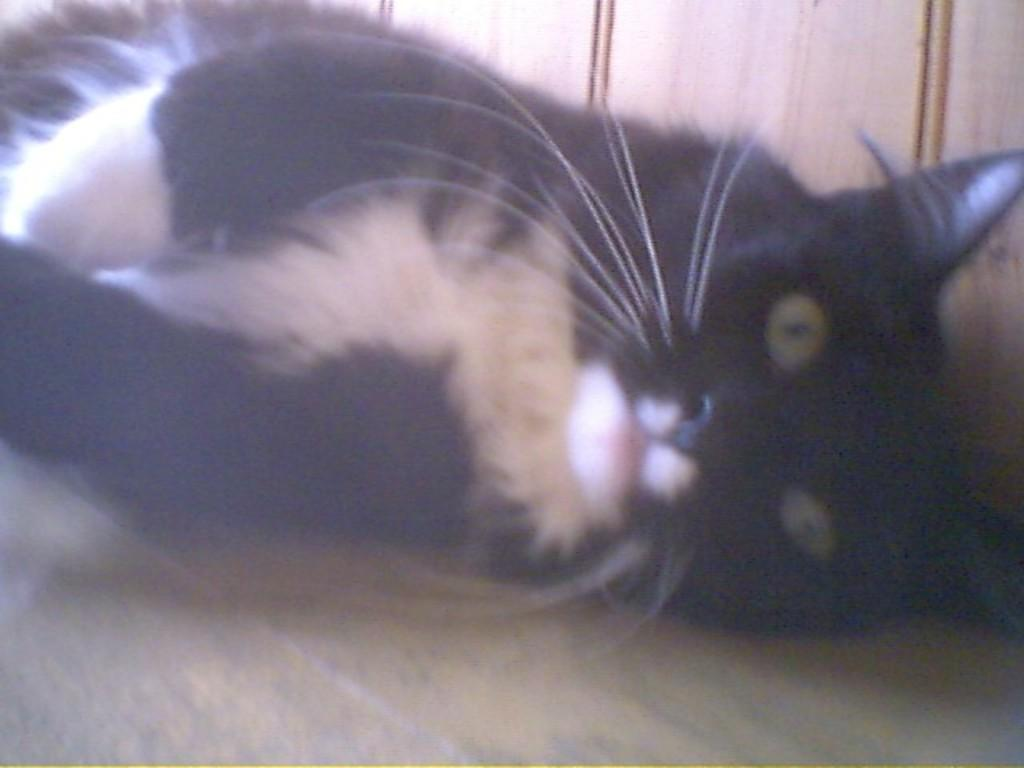What is the main subject in the center of the image? There is a cat in the center of the image. What type of surface is visible at the bottom of the image? There is a floor visible at the bottom of the image. What is the limit of the cat's disgust in the image? There is no indication of the cat's emotions or limits in the image, as it only shows the cat and the floor. 